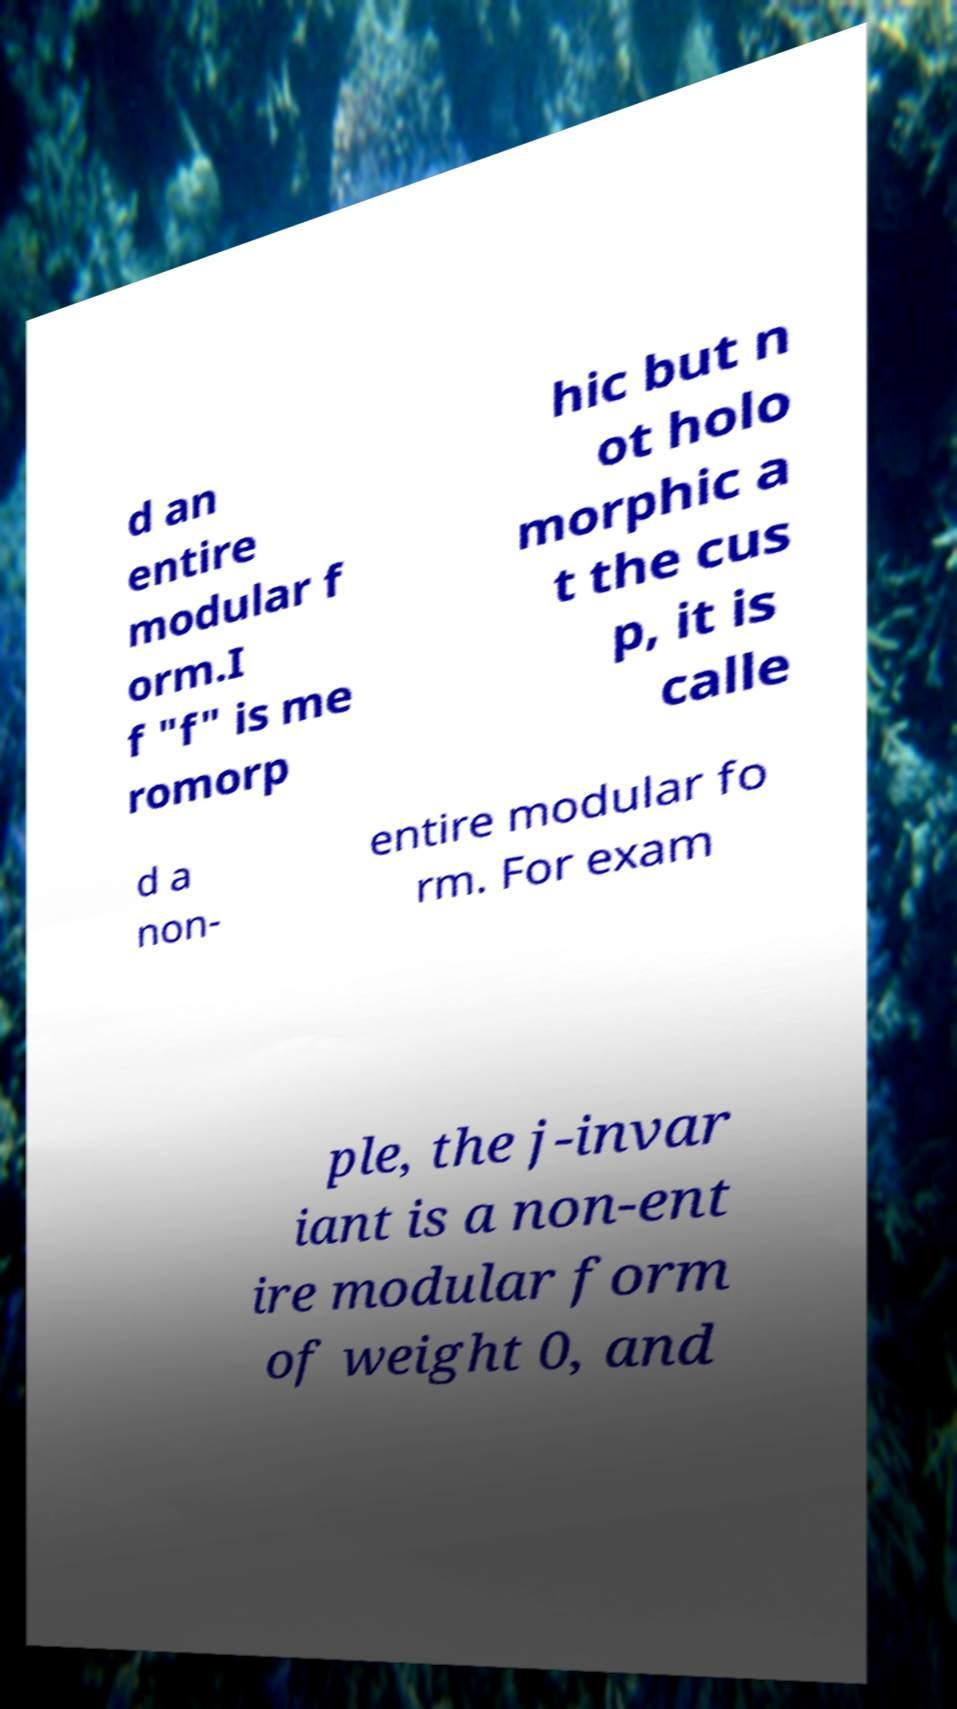For documentation purposes, I need the text within this image transcribed. Could you provide that? d an entire modular f orm.I f "f" is me romorp hic but n ot holo morphic a t the cus p, it is calle d a non- entire modular fo rm. For exam ple, the j-invar iant is a non-ent ire modular form of weight 0, and 